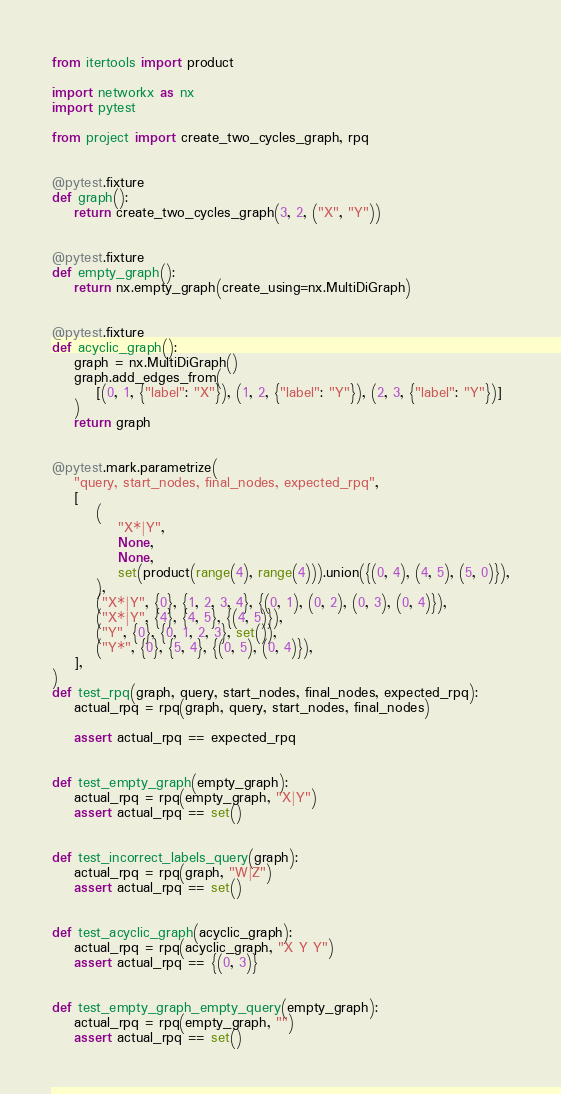Convert code to text. <code><loc_0><loc_0><loc_500><loc_500><_Python_>from itertools import product

import networkx as nx
import pytest

from project import create_two_cycles_graph, rpq


@pytest.fixture
def graph():
    return create_two_cycles_graph(3, 2, ("X", "Y"))


@pytest.fixture
def empty_graph():
    return nx.empty_graph(create_using=nx.MultiDiGraph)


@pytest.fixture
def acyclic_graph():
    graph = nx.MultiDiGraph()
    graph.add_edges_from(
        [(0, 1, {"label": "X"}), (1, 2, {"label": "Y"}), (2, 3, {"label": "Y"})]
    )
    return graph


@pytest.mark.parametrize(
    "query, start_nodes, final_nodes, expected_rpq",
    [
        (
            "X*|Y",
            None,
            None,
            set(product(range(4), range(4))).union({(0, 4), (4, 5), (5, 0)}),
        ),
        ("X*|Y", {0}, {1, 2, 3, 4}, {(0, 1), (0, 2), (0, 3), (0, 4)}),
        ("X*|Y", {4}, {4, 5}, {(4, 5)}),
        ("Y", {0}, {0, 1, 2, 3}, set()),
        ("Y*", {0}, {5, 4}, {(0, 5), (0, 4)}),
    ],
)
def test_rpq(graph, query, start_nodes, final_nodes, expected_rpq):
    actual_rpq = rpq(graph, query, start_nodes, final_nodes)

    assert actual_rpq == expected_rpq


def test_empty_graph(empty_graph):
    actual_rpq = rpq(empty_graph, "X|Y")
    assert actual_rpq == set()


def test_incorrect_labels_query(graph):
    actual_rpq = rpq(graph, "W|Z")
    assert actual_rpq == set()


def test_acyclic_graph(acyclic_graph):
    actual_rpq = rpq(acyclic_graph, "X Y Y")
    assert actual_rpq == {(0, 3)}


def test_empty_graph_empty_query(empty_graph):
    actual_rpq = rpq(empty_graph, "")
    assert actual_rpq == set()
</code> 